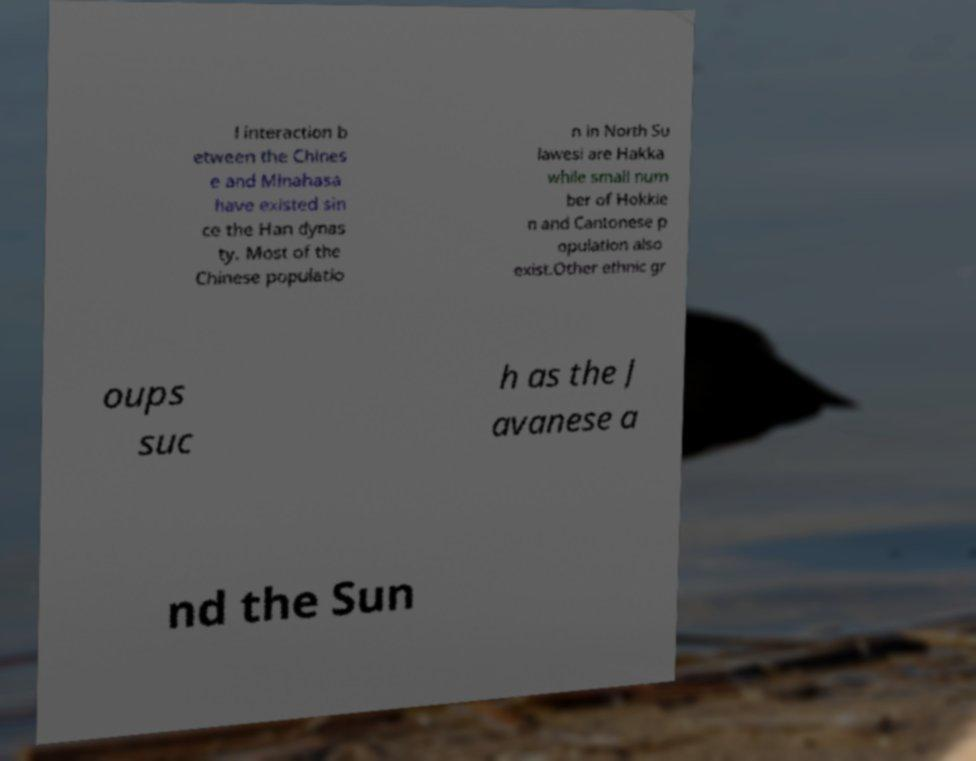Can you read and provide the text displayed in the image?This photo seems to have some interesting text. Can you extract and type it out for me? l interaction b etween the Chines e and Minahasa have existed sin ce the Han dynas ty. Most of the Chinese populatio n in North Su lawesi are Hakka while small num ber of Hokkie n and Cantonese p opulation also exist.Other ethnic gr oups suc h as the J avanese a nd the Sun 